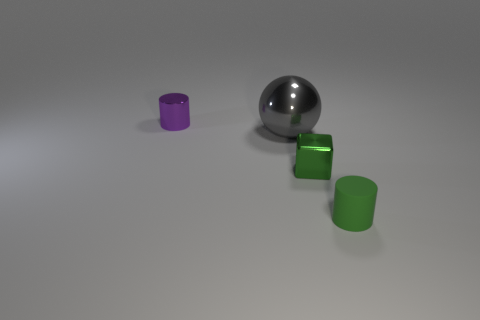Add 1 small green objects. How many objects exist? 5 Subtract all cubes. How many objects are left? 3 Add 3 gray metal objects. How many gray metal objects exist? 4 Subtract 0 brown balls. How many objects are left? 4 Subtract all metal blocks. Subtract all large blocks. How many objects are left? 3 Add 4 metal cubes. How many metal cubes are left? 5 